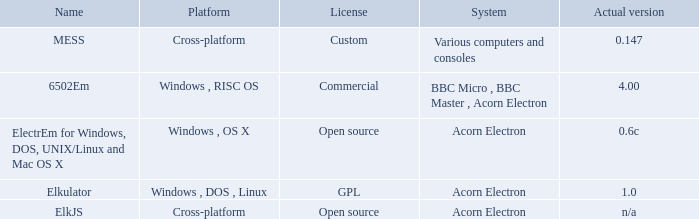What is the system called that is named ELKJS? Acorn Electron. 